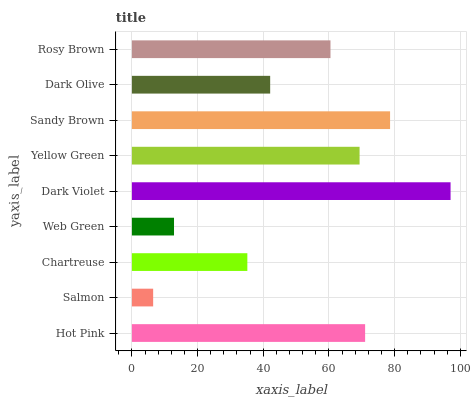Is Salmon the minimum?
Answer yes or no. Yes. Is Dark Violet the maximum?
Answer yes or no. Yes. Is Chartreuse the minimum?
Answer yes or no. No. Is Chartreuse the maximum?
Answer yes or no. No. Is Chartreuse greater than Salmon?
Answer yes or no. Yes. Is Salmon less than Chartreuse?
Answer yes or no. Yes. Is Salmon greater than Chartreuse?
Answer yes or no. No. Is Chartreuse less than Salmon?
Answer yes or no. No. Is Rosy Brown the high median?
Answer yes or no. Yes. Is Rosy Brown the low median?
Answer yes or no. Yes. Is Hot Pink the high median?
Answer yes or no. No. Is Sandy Brown the low median?
Answer yes or no. No. 